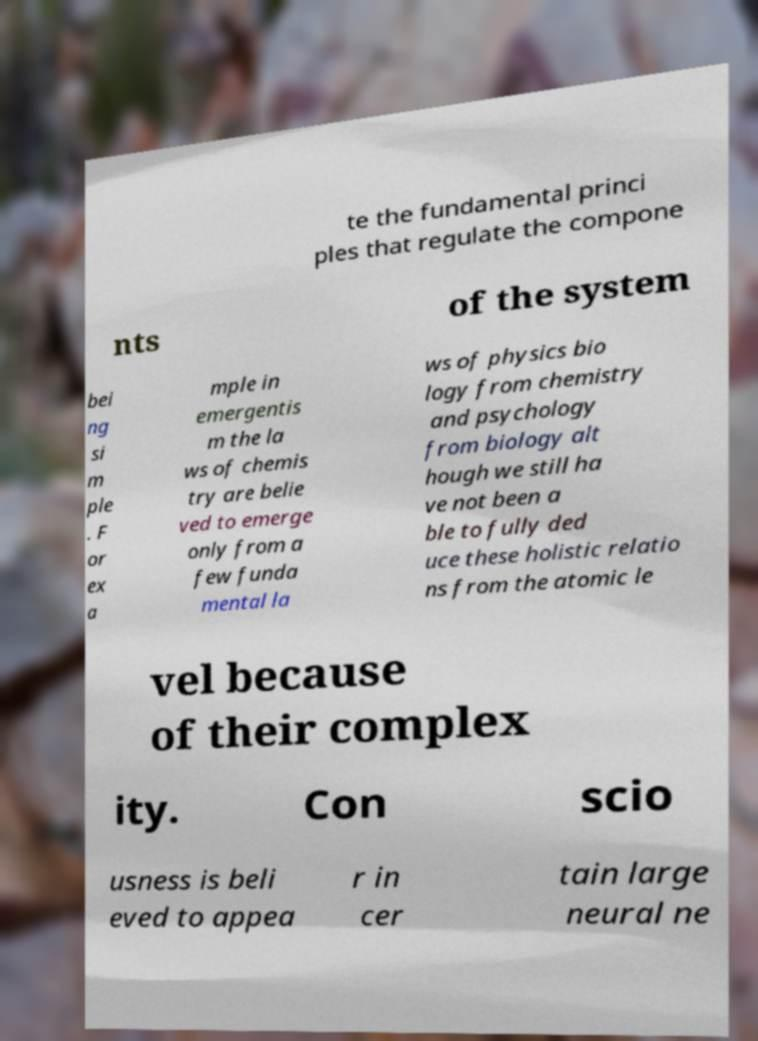Please identify and transcribe the text found in this image. te the fundamental princi ples that regulate the compone nts of the system bei ng si m ple . F or ex a mple in emergentis m the la ws of chemis try are belie ved to emerge only from a few funda mental la ws of physics bio logy from chemistry and psychology from biology alt hough we still ha ve not been a ble to fully ded uce these holistic relatio ns from the atomic le vel because of their complex ity. Con scio usness is beli eved to appea r in cer tain large neural ne 